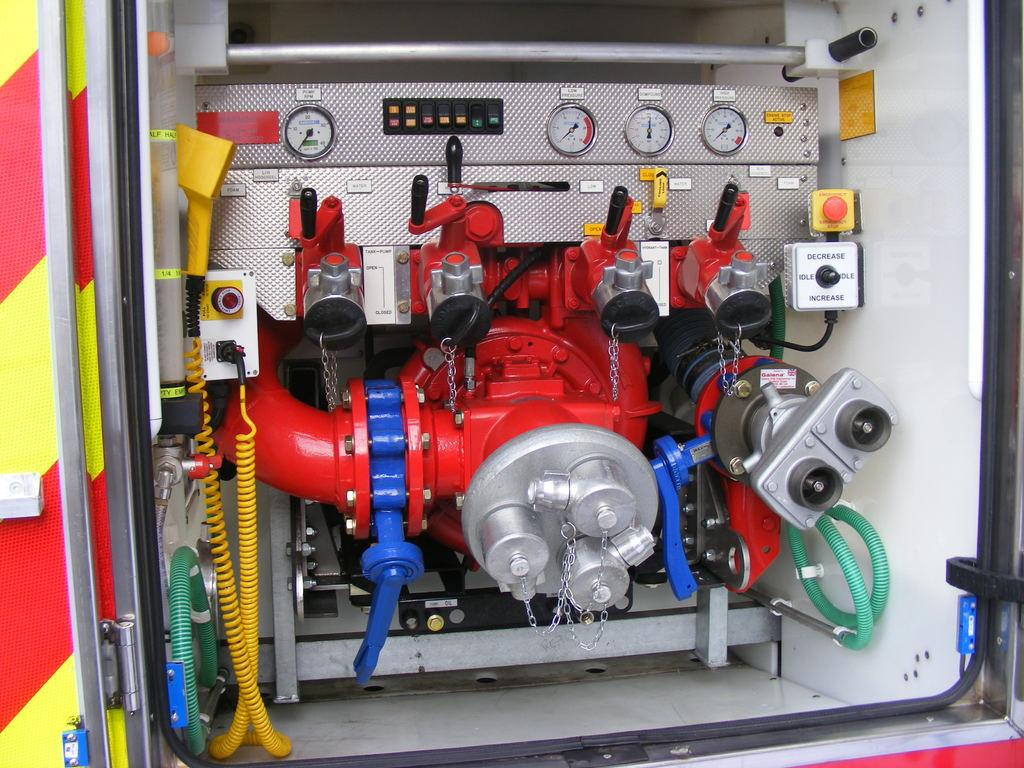What type of machine is in the image? There is a red and silver machine engine in the image. Where is the machine engine located in the image? The machine engine is in the front of the image. What can be found on the top of the machine engine? There are pressure gauges on the top of the machine engine. What else is visible on the left side of the image? There is a red and yellow van door on the left side of the image. What type of key is used to operate the machine engine in the image? There is no key visible in the image, and the operation of the machine engine is not described in the provided facts. 